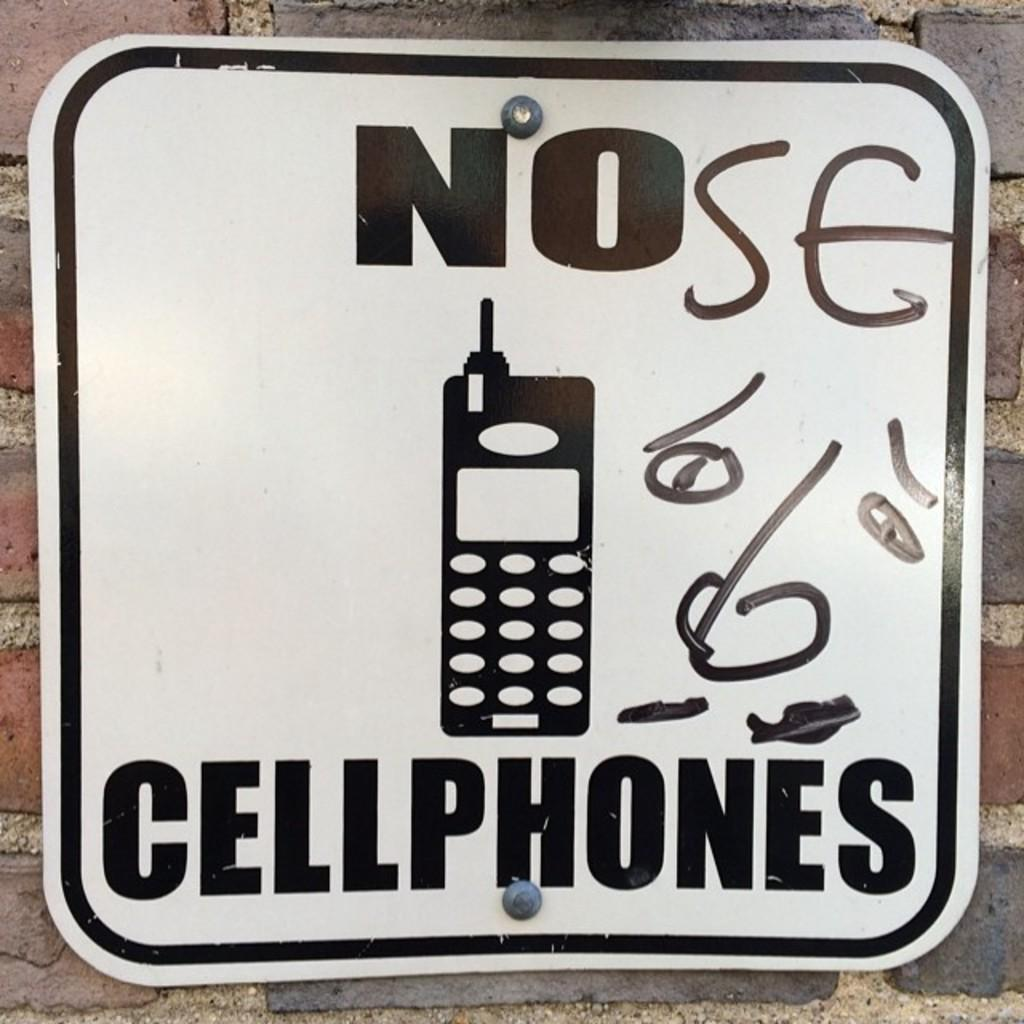<image>
Summarize the visual content of the image. a white item with the word cellphones on them 